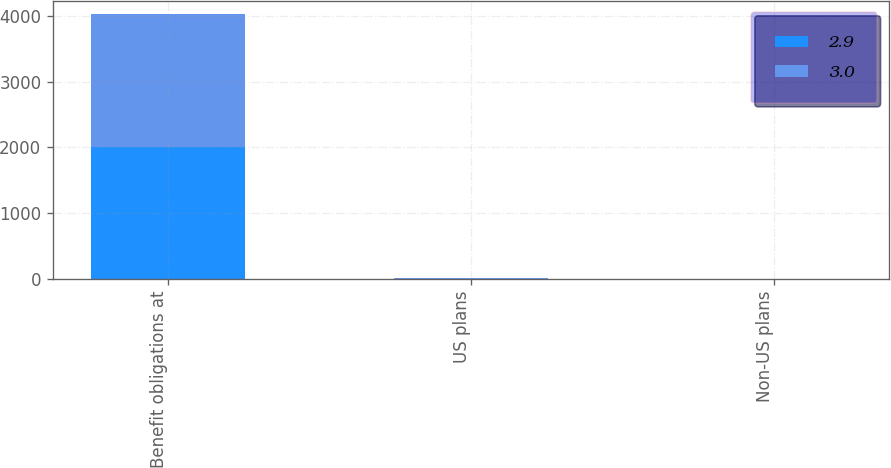Convert chart. <chart><loc_0><loc_0><loc_500><loc_500><stacked_bar_chart><ecel><fcel>Benefit obligations at<fcel>US plans<fcel>Non-US plans<nl><fcel>2.9<fcel>2015<fcel>4.3<fcel>3.6<nl><fcel>3<fcel>2014<fcel>4<fcel>3.8<nl></chart> 